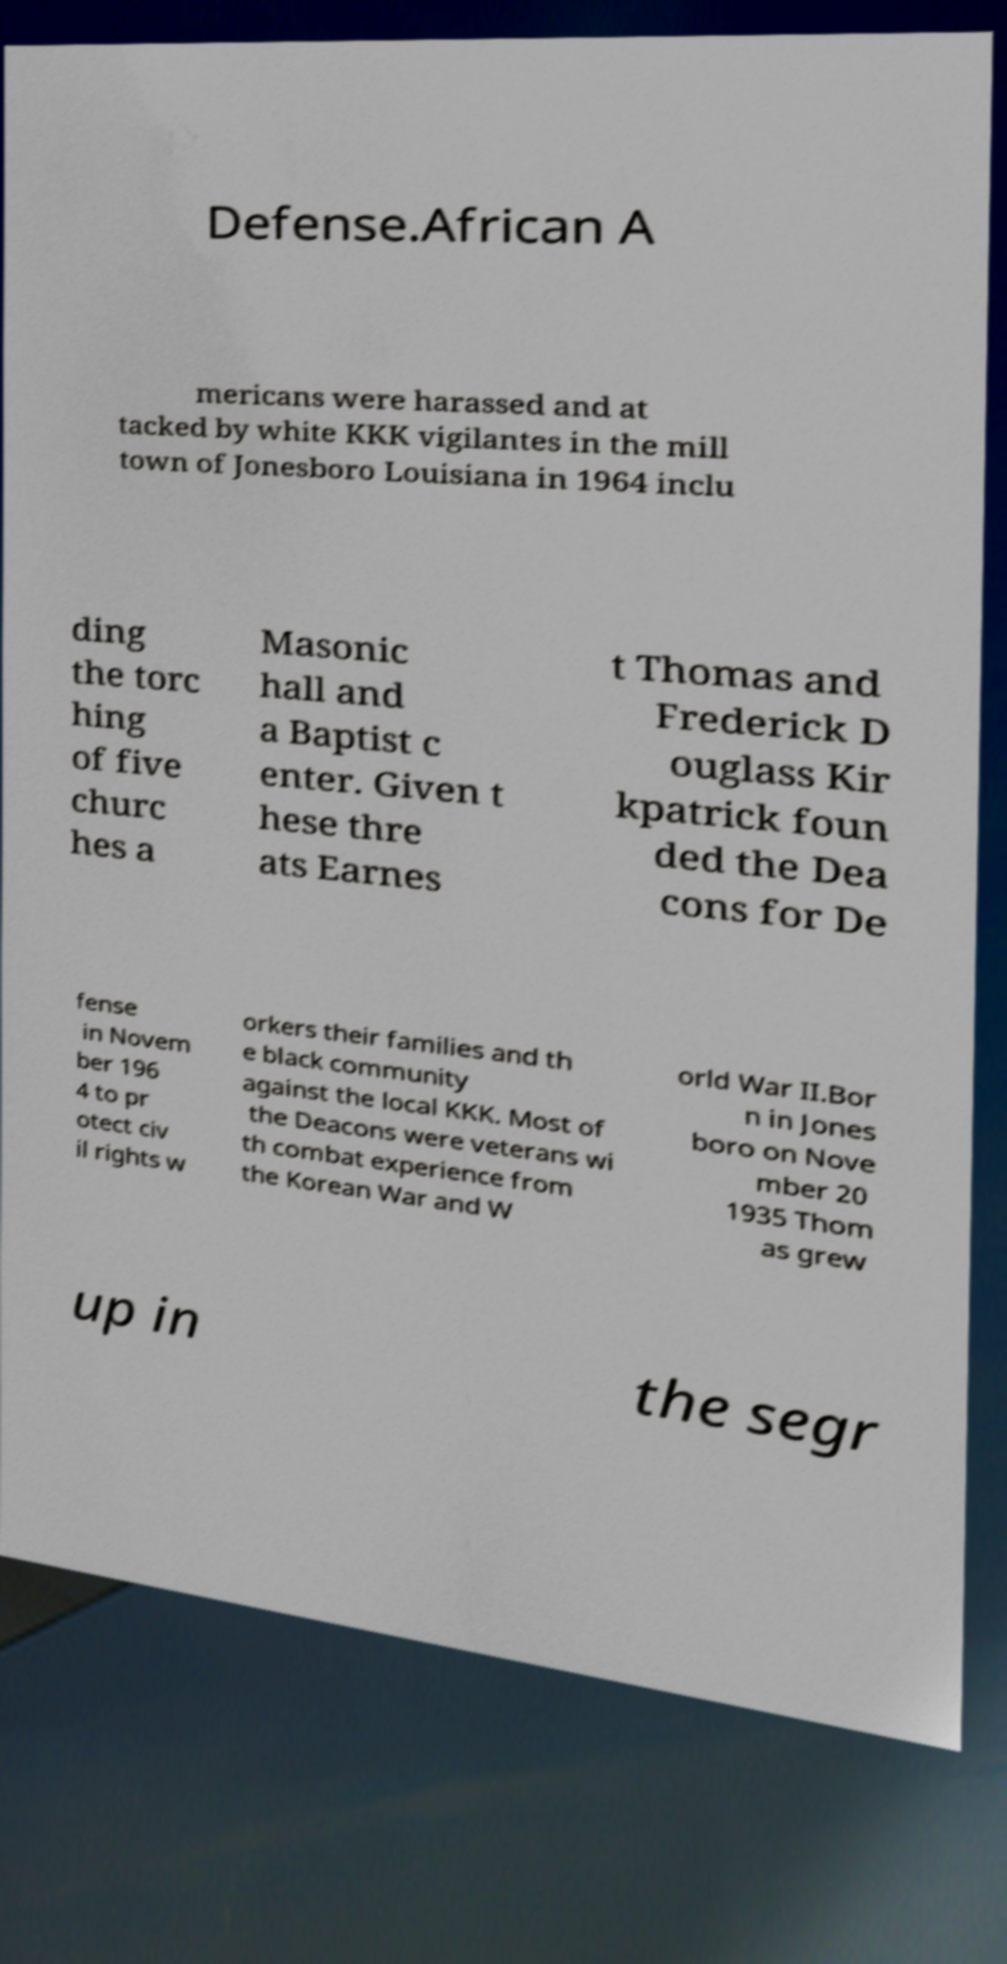Can you read and provide the text displayed in the image?This photo seems to have some interesting text. Can you extract and type it out for me? Defense.African A mericans were harassed and at tacked by white KKK vigilantes in the mill town of Jonesboro Louisiana in 1964 inclu ding the torc hing of five churc hes a Masonic hall and a Baptist c enter. Given t hese thre ats Earnes t Thomas and Frederick D ouglass Kir kpatrick foun ded the Dea cons for De fense in Novem ber 196 4 to pr otect civ il rights w orkers their families and th e black community against the local KKK. Most of the Deacons were veterans wi th combat experience from the Korean War and W orld War II.Bor n in Jones boro on Nove mber 20 1935 Thom as grew up in the segr 